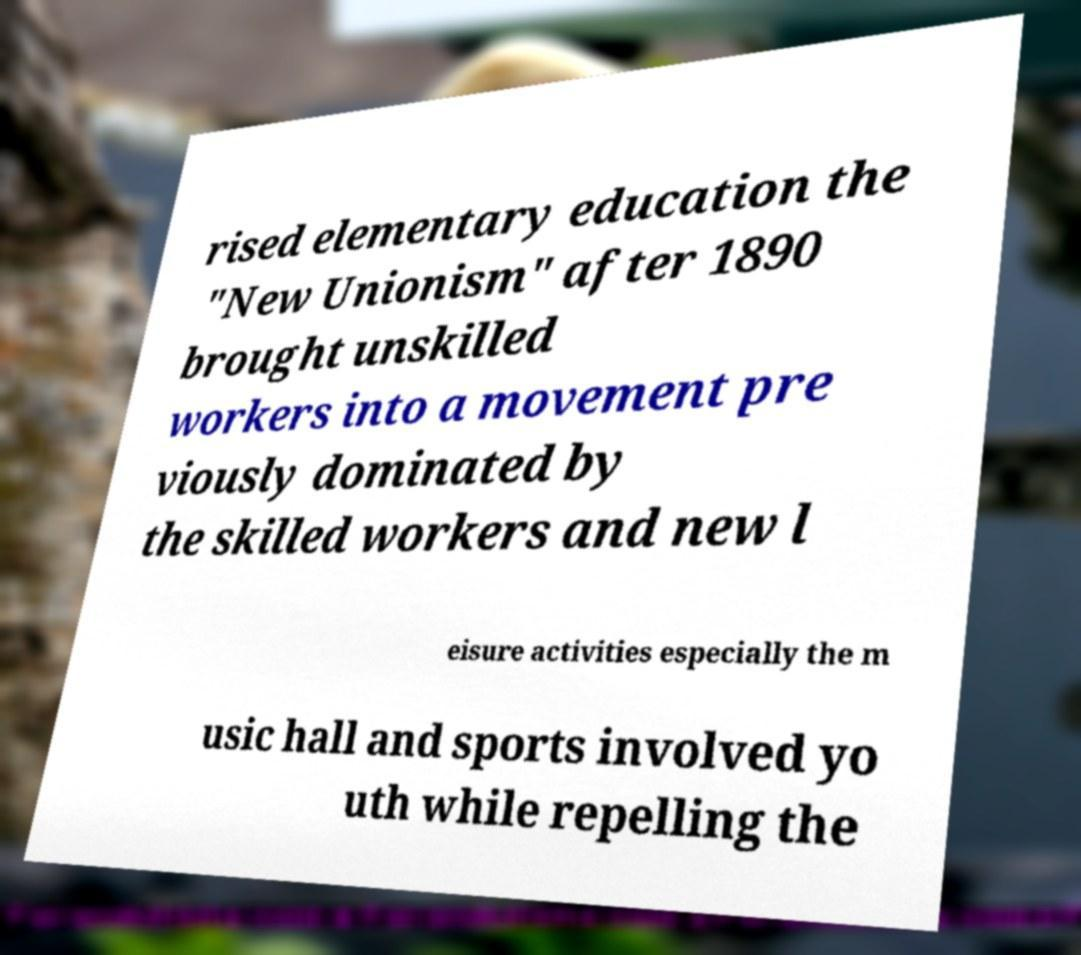Please read and relay the text visible in this image. What does it say? rised elementary education the "New Unionism" after 1890 brought unskilled workers into a movement pre viously dominated by the skilled workers and new l eisure activities especially the m usic hall and sports involved yo uth while repelling the 